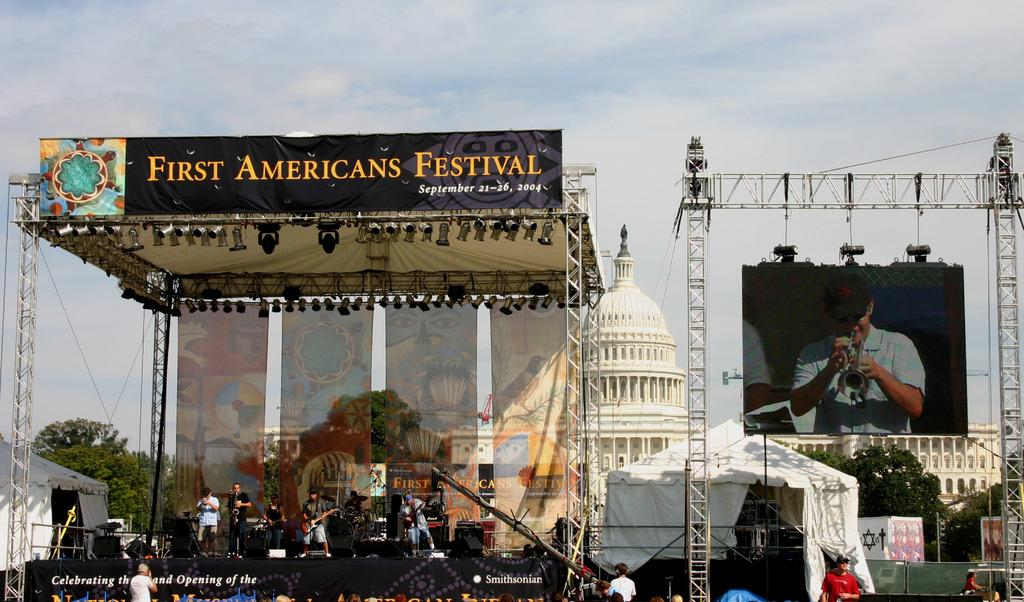<image>
Render a clear and concise summary of the photo. A stage infront of the white House on which a banner says Americans Festival. 